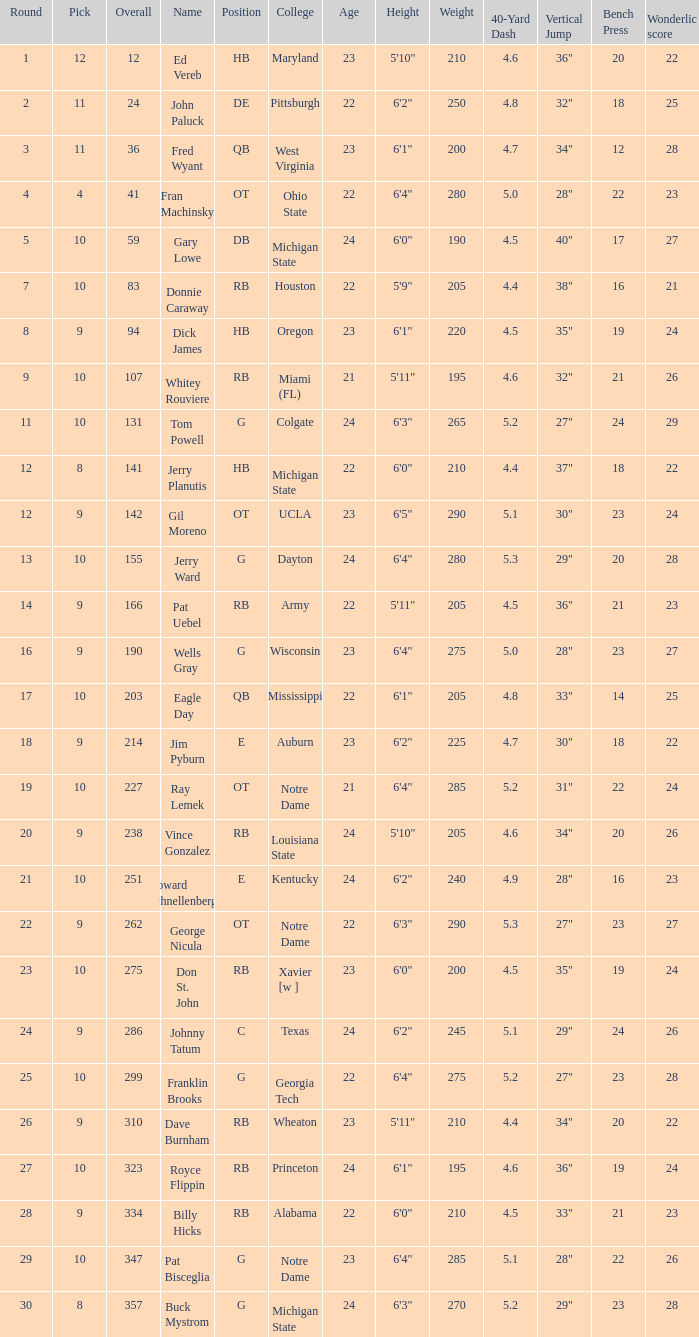What is the highest round number for donnie caraway? 7.0. 